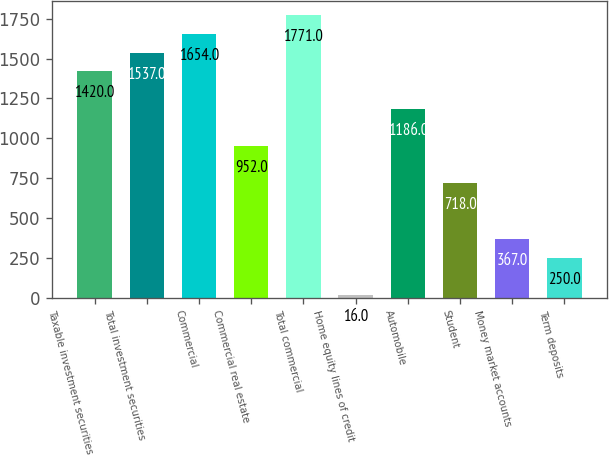Convert chart. <chart><loc_0><loc_0><loc_500><loc_500><bar_chart><fcel>Taxable investment securities<fcel>Total investment securities<fcel>Commercial<fcel>Commercial real estate<fcel>Total commercial<fcel>Home equity lines of credit<fcel>Automobile<fcel>Student<fcel>Money market accounts<fcel>Term deposits<nl><fcel>1420<fcel>1537<fcel>1654<fcel>952<fcel>1771<fcel>16<fcel>1186<fcel>718<fcel>367<fcel>250<nl></chart> 